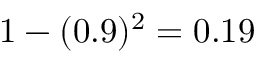<formula> <loc_0><loc_0><loc_500><loc_500>1 - ( 0 . 9 ) ^ { 2 } = 0 . 1 9</formula> 